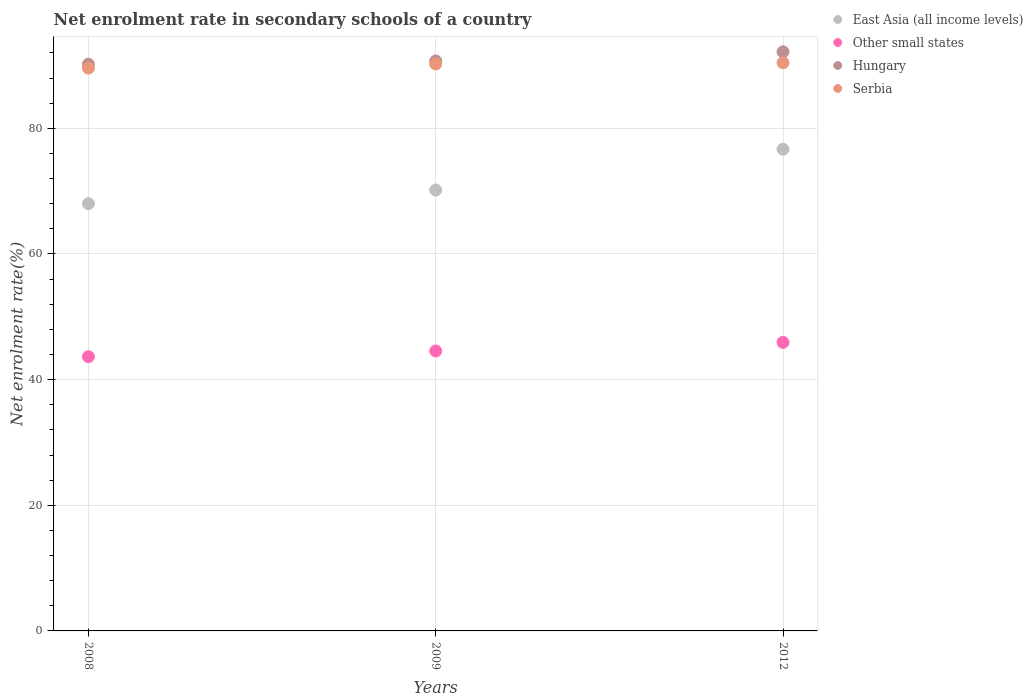How many different coloured dotlines are there?
Provide a succinct answer. 4. What is the net enrolment rate in secondary schools in Hungary in 2008?
Offer a very short reply. 90.2. Across all years, what is the maximum net enrolment rate in secondary schools in Other small states?
Your response must be concise. 45.93. Across all years, what is the minimum net enrolment rate in secondary schools in Other small states?
Offer a terse response. 43.64. What is the total net enrolment rate in secondary schools in Serbia in the graph?
Make the answer very short. 270.27. What is the difference between the net enrolment rate in secondary schools in East Asia (all income levels) in 2008 and that in 2009?
Offer a very short reply. -2.17. What is the difference between the net enrolment rate in secondary schools in East Asia (all income levels) in 2012 and the net enrolment rate in secondary schools in Hungary in 2009?
Your answer should be compact. -14.05. What is the average net enrolment rate in secondary schools in East Asia (all income levels) per year?
Provide a succinct answer. 71.61. In the year 2009, what is the difference between the net enrolment rate in secondary schools in Other small states and net enrolment rate in secondary schools in Hungary?
Keep it short and to the point. -46.16. In how many years, is the net enrolment rate in secondary schools in Hungary greater than 72 %?
Provide a short and direct response. 3. What is the ratio of the net enrolment rate in secondary schools in East Asia (all income levels) in 2008 to that in 2009?
Offer a very short reply. 0.97. Is the net enrolment rate in secondary schools in Other small states in 2008 less than that in 2009?
Your answer should be very brief. Yes. Is the difference between the net enrolment rate in secondary schools in Other small states in 2008 and 2012 greater than the difference between the net enrolment rate in secondary schools in Hungary in 2008 and 2012?
Ensure brevity in your answer.  No. What is the difference between the highest and the second highest net enrolment rate in secondary schools in Serbia?
Your answer should be compact. 0.2. What is the difference between the highest and the lowest net enrolment rate in secondary schools in Other small states?
Your answer should be compact. 2.28. In how many years, is the net enrolment rate in secondary schools in Serbia greater than the average net enrolment rate in secondary schools in Serbia taken over all years?
Make the answer very short. 2. Is the net enrolment rate in secondary schools in Other small states strictly greater than the net enrolment rate in secondary schools in Hungary over the years?
Offer a terse response. No. How many years are there in the graph?
Your answer should be compact. 3. Does the graph contain any zero values?
Your response must be concise. No. Does the graph contain grids?
Your answer should be compact. Yes. Where does the legend appear in the graph?
Ensure brevity in your answer.  Top right. What is the title of the graph?
Give a very brief answer. Net enrolment rate in secondary schools of a country. Does "Panama" appear as one of the legend labels in the graph?
Your response must be concise. No. What is the label or title of the X-axis?
Your response must be concise. Years. What is the label or title of the Y-axis?
Provide a succinct answer. Net enrolment rate(%). What is the Net enrolment rate(%) in East Asia (all income levels) in 2008?
Give a very brief answer. 68. What is the Net enrolment rate(%) in Other small states in 2008?
Your answer should be compact. 43.64. What is the Net enrolment rate(%) in Hungary in 2008?
Make the answer very short. 90.2. What is the Net enrolment rate(%) of Serbia in 2008?
Offer a terse response. 89.59. What is the Net enrolment rate(%) of East Asia (all income levels) in 2009?
Offer a very short reply. 70.18. What is the Net enrolment rate(%) of Other small states in 2009?
Offer a very short reply. 44.55. What is the Net enrolment rate(%) in Hungary in 2009?
Your response must be concise. 90.72. What is the Net enrolment rate(%) in Serbia in 2009?
Offer a terse response. 90.24. What is the Net enrolment rate(%) of East Asia (all income levels) in 2012?
Your response must be concise. 76.67. What is the Net enrolment rate(%) of Other small states in 2012?
Ensure brevity in your answer.  45.93. What is the Net enrolment rate(%) in Hungary in 2012?
Your answer should be compact. 92.17. What is the Net enrolment rate(%) of Serbia in 2012?
Your answer should be compact. 90.44. Across all years, what is the maximum Net enrolment rate(%) in East Asia (all income levels)?
Keep it short and to the point. 76.67. Across all years, what is the maximum Net enrolment rate(%) in Other small states?
Provide a short and direct response. 45.93. Across all years, what is the maximum Net enrolment rate(%) in Hungary?
Offer a terse response. 92.17. Across all years, what is the maximum Net enrolment rate(%) of Serbia?
Your answer should be very brief. 90.44. Across all years, what is the minimum Net enrolment rate(%) of East Asia (all income levels)?
Offer a very short reply. 68. Across all years, what is the minimum Net enrolment rate(%) of Other small states?
Your answer should be very brief. 43.64. Across all years, what is the minimum Net enrolment rate(%) of Hungary?
Provide a succinct answer. 90.2. Across all years, what is the minimum Net enrolment rate(%) of Serbia?
Your answer should be compact. 89.59. What is the total Net enrolment rate(%) in East Asia (all income levels) in the graph?
Keep it short and to the point. 214.84. What is the total Net enrolment rate(%) in Other small states in the graph?
Provide a short and direct response. 134.13. What is the total Net enrolment rate(%) of Hungary in the graph?
Your answer should be very brief. 273.09. What is the total Net enrolment rate(%) in Serbia in the graph?
Provide a succinct answer. 270.27. What is the difference between the Net enrolment rate(%) in East Asia (all income levels) in 2008 and that in 2009?
Make the answer very short. -2.17. What is the difference between the Net enrolment rate(%) of Other small states in 2008 and that in 2009?
Offer a terse response. -0.91. What is the difference between the Net enrolment rate(%) of Hungary in 2008 and that in 2009?
Your answer should be very brief. -0.52. What is the difference between the Net enrolment rate(%) in Serbia in 2008 and that in 2009?
Keep it short and to the point. -0.65. What is the difference between the Net enrolment rate(%) of East Asia (all income levels) in 2008 and that in 2012?
Keep it short and to the point. -8.67. What is the difference between the Net enrolment rate(%) in Other small states in 2008 and that in 2012?
Offer a terse response. -2.28. What is the difference between the Net enrolment rate(%) of Hungary in 2008 and that in 2012?
Provide a short and direct response. -1.98. What is the difference between the Net enrolment rate(%) in Serbia in 2008 and that in 2012?
Your answer should be very brief. -0.85. What is the difference between the Net enrolment rate(%) of East Asia (all income levels) in 2009 and that in 2012?
Your answer should be compact. -6.49. What is the difference between the Net enrolment rate(%) in Other small states in 2009 and that in 2012?
Offer a terse response. -1.38. What is the difference between the Net enrolment rate(%) in Hungary in 2009 and that in 2012?
Keep it short and to the point. -1.46. What is the difference between the Net enrolment rate(%) of Serbia in 2009 and that in 2012?
Make the answer very short. -0.2. What is the difference between the Net enrolment rate(%) in East Asia (all income levels) in 2008 and the Net enrolment rate(%) in Other small states in 2009?
Offer a terse response. 23.45. What is the difference between the Net enrolment rate(%) of East Asia (all income levels) in 2008 and the Net enrolment rate(%) of Hungary in 2009?
Provide a succinct answer. -22.72. What is the difference between the Net enrolment rate(%) of East Asia (all income levels) in 2008 and the Net enrolment rate(%) of Serbia in 2009?
Your answer should be very brief. -22.24. What is the difference between the Net enrolment rate(%) of Other small states in 2008 and the Net enrolment rate(%) of Hungary in 2009?
Keep it short and to the point. -47.07. What is the difference between the Net enrolment rate(%) of Other small states in 2008 and the Net enrolment rate(%) of Serbia in 2009?
Your response must be concise. -46.6. What is the difference between the Net enrolment rate(%) of Hungary in 2008 and the Net enrolment rate(%) of Serbia in 2009?
Your response must be concise. -0.04. What is the difference between the Net enrolment rate(%) in East Asia (all income levels) in 2008 and the Net enrolment rate(%) in Other small states in 2012?
Your answer should be compact. 22.07. What is the difference between the Net enrolment rate(%) in East Asia (all income levels) in 2008 and the Net enrolment rate(%) in Hungary in 2012?
Provide a short and direct response. -24.17. What is the difference between the Net enrolment rate(%) in East Asia (all income levels) in 2008 and the Net enrolment rate(%) in Serbia in 2012?
Ensure brevity in your answer.  -22.44. What is the difference between the Net enrolment rate(%) of Other small states in 2008 and the Net enrolment rate(%) of Hungary in 2012?
Keep it short and to the point. -48.53. What is the difference between the Net enrolment rate(%) in Other small states in 2008 and the Net enrolment rate(%) in Serbia in 2012?
Your answer should be compact. -46.79. What is the difference between the Net enrolment rate(%) of Hungary in 2008 and the Net enrolment rate(%) of Serbia in 2012?
Your response must be concise. -0.24. What is the difference between the Net enrolment rate(%) in East Asia (all income levels) in 2009 and the Net enrolment rate(%) in Other small states in 2012?
Offer a very short reply. 24.25. What is the difference between the Net enrolment rate(%) of East Asia (all income levels) in 2009 and the Net enrolment rate(%) of Hungary in 2012?
Ensure brevity in your answer.  -22. What is the difference between the Net enrolment rate(%) in East Asia (all income levels) in 2009 and the Net enrolment rate(%) in Serbia in 2012?
Provide a short and direct response. -20.26. What is the difference between the Net enrolment rate(%) of Other small states in 2009 and the Net enrolment rate(%) of Hungary in 2012?
Your response must be concise. -47.62. What is the difference between the Net enrolment rate(%) of Other small states in 2009 and the Net enrolment rate(%) of Serbia in 2012?
Offer a terse response. -45.88. What is the difference between the Net enrolment rate(%) of Hungary in 2009 and the Net enrolment rate(%) of Serbia in 2012?
Your response must be concise. 0.28. What is the average Net enrolment rate(%) of East Asia (all income levels) per year?
Offer a terse response. 71.61. What is the average Net enrolment rate(%) of Other small states per year?
Offer a terse response. 44.71. What is the average Net enrolment rate(%) of Hungary per year?
Offer a very short reply. 91.03. What is the average Net enrolment rate(%) in Serbia per year?
Keep it short and to the point. 90.09. In the year 2008, what is the difference between the Net enrolment rate(%) in East Asia (all income levels) and Net enrolment rate(%) in Other small states?
Ensure brevity in your answer.  24.36. In the year 2008, what is the difference between the Net enrolment rate(%) in East Asia (all income levels) and Net enrolment rate(%) in Hungary?
Offer a terse response. -22.19. In the year 2008, what is the difference between the Net enrolment rate(%) in East Asia (all income levels) and Net enrolment rate(%) in Serbia?
Give a very brief answer. -21.59. In the year 2008, what is the difference between the Net enrolment rate(%) of Other small states and Net enrolment rate(%) of Hungary?
Keep it short and to the point. -46.55. In the year 2008, what is the difference between the Net enrolment rate(%) of Other small states and Net enrolment rate(%) of Serbia?
Offer a very short reply. -45.94. In the year 2008, what is the difference between the Net enrolment rate(%) in Hungary and Net enrolment rate(%) in Serbia?
Keep it short and to the point. 0.61. In the year 2009, what is the difference between the Net enrolment rate(%) of East Asia (all income levels) and Net enrolment rate(%) of Other small states?
Provide a succinct answer. 25.62. In the year 2009, what is the difference between the Net enrolment rate(%) in East Asia (all income levels) and Net enrolment rate(%) in Hungary?
Provide a succinct answer. -20.54. In the year 2009, what is the difference between the Net enrolment rate(%) of East Asia (all income levels) and Net enrolment rate(%) of Serbia?
Provide a short and direct response. -20.07. In the year 2009, what is the difference between the Net enrolment rate(%) of Other small states and Net enrolment rate(%) of Hungary?
Your answer should be very brief. -46.16. In the year 2009, what is the difference between the Net enrolment rate(%) of Other small states and Net enrolment rate(%) of Serbia?
Provide a succinct answer. -45.69. In the year 2009, what is the difference between the Net enrolment rate(%) of Hungary and Net enrolment rate(%) of Serbia?
Offer a very short reply. 0.48. In the year 2012, what is the difference between the Net enrolment rate(%) in East Asia (all income levels) and Net enrolment rate(%) in Other small states?
Offer a terse response. 30.74. In the year 2012, what is the difference between the Net enrolment rate(%) in East Asia (all income levels) and Net enrolment rate(%) in Hungary?
Your answer should be compact. -15.51. In the year 2012, what is the difference between the Net enrolment rate(%) in East Asia (all income levels) and Net enrolment rate(%) in Serbia?
Provide a succinct answer. -13.77. In the year 2012, what is the difference between the Net enrolment rate(%) in Other small states and Net enrolment rate(%) in Hungary?
Give a very brief answer. -46.24. In the year 2012, what is the difference between the Net enrolment rate(%) of Other small states and Net enrolment rate(%) of Serbia?
Your answer should be compact. -44.51. In the year 2012, what is the difference between the Net enrolment rate(%) in Hungary and Net enrolment rate(%) in Serbia?
Give a very brief answer. 1.74. What is the ratio of the Net enrolment rate(%) of East Asia (all income levels) in 2008 to that in 2009?
Offer a terse response. 0.97. What is the ratio of the Net enrolment rate(%) in Other small states in 2008 to that in 2009?
Provide a succinct answer. 0.98. What is the ratio of the Net enrolment rate(%) of Hungary in 2008 to that in 2009?
Provide a short and direct response. 0.99. What is the ratio of the Net enrolment rate(%) of Serbia in 2008 to that in 2009?
Offer a very short reply. 0.99. What is the ratio of the Net enrolment rate(%) of East Asia (all income levels) in 2008 to that in 2012?
Ensure brevity in your answer.  0.89. What is the ratio of the Net enrolment rate(%) in Other small states in 2008 to that in 2012?
Provide a short and direct response. 0.95. What is the ratio of the Net enrolment rate(%) in Hungary in 2008 to that in 2012?
Give a very brief answer. 0.98. What is the ratio of the Net enrolment rate(%) of Serbia in 2008 to that in 2012?
Ensure brevity in your answer.  0.99. What is the ratio of the Net enrolment rate(%) in East Asia (all income levels) in 2009 to that in 2012?
Offer a very short reply. 0.92. What is the ratio of the Net enrolment rate(%) of Other small states in 2009 to that in 2012?
Your response must be concise. 0.97. What is the ratio of the Net enrolment rate(%) of Hungary in 2009 to that in 2012?
Ensure brevity in your answer.  0.98. What is the ratio of the Net enrolment rate(%) of Serbia in 2009 to that in 2012?
Your response must be concise. 1. What is the difference between the highest and the second highest Net enrolment rate(%) in East Asia (all income levels)?
Give a very brief answer. 6.49. What is the difference between the highest and the second highest Net enrolment rate(%) in Other small states?
Your answer should be very brief. 1.38. What is the difference between the highest and the second highest Net enrolment rate(%) of Hungary?
Give a very brief answer. 1.46. What is the difference between the highest and the second highest Net enrolment rate(%) in Serbia?
Your answer should be very brief. 0.2. What is the difference between the highest and the lowest Net enrolment rate(%) in East Asia (all income levels)?
Your answer should be very brief. 8.67. What is the difference between the highest and the lowest Net enrolment rate(%) of Other small states?
Keep it short and to the point. 2.28. What is the difference between the highest and the lowest Net enrolment rate(%) in Hungary?
Your answer should be very brief. 1.98. What is the difference between the highest and the lowest Net enrolment rate(%) of Serbia?
Give a very brief answer. 0.85. 